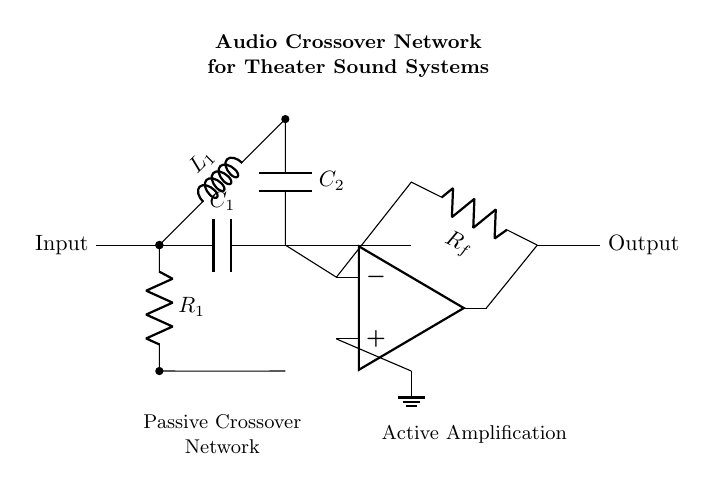What type of circuit is this? This is a hybrid crossover network that combines both passive components (capacitors, inductors, and resistors) and an active component (an operational amplifier). The presence of these components indicates that the circuit serves to split audio signals into different frequency ranges for various output devices.
Answer: Hybrid crossover network What component is responsible for high frequency signal filtering? The capacitor labeled C1 is connected in series to the input and allows high-frequency signals to pass while blocking low frequencies. Its role is essential in the high-pass filter section of the circuit.
Answer: Capacitor What is the function of the operational amplifier in this circuit? The operational amplifier is used for active amplification, allowing the circuit to strengthen the signal after it has been filtered by the passive components. It takes the filtered audio signal and amplifies it for output.
Answer: Active amplification Which components form the passive crossover network? The passive crossover network is comprised of resistors, capacitors, and inductors that work together to filter audio signals without requiring external power. In this diagram, R1, L1, C1, and C2 are part of this network.
Answer: R1, C1, L1, C2 How does the feedback network influence the operation of the circuit? The feedback network, which includes resistor Rf, helps to control the gain of the operational amplifier. By providing feedback from the output signal back to the input, it stabilizes the gain and keeps the output signal at a desired level.
Answer: Controls gain What does the label "Passive Crossover Network" indicate? This label specifies the section of the circuit that utilizes passive components to divide the audio signal into different frequency ranges before it is amplified by the operational amplifier. It distinguishes the filtering part from the amplification part.
Answer: Filtering section 